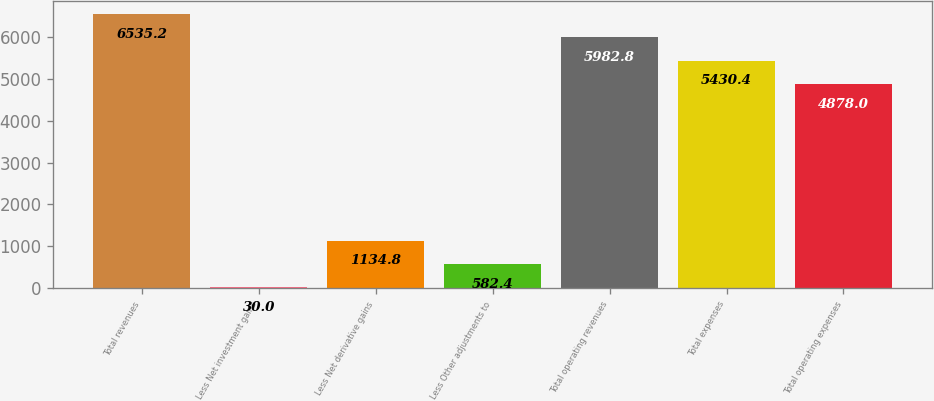<chart> <loc_0><loc_0><loc_500><loc_500><bar_chart><fcel>Total revenues<fcel>Less Net investment gains<fcel>Less Net derivative gains<fcel>Less Other adjustments to<fcel>Total operating revenues<fcel>Total expenses<fcel>Total operating expenses<nl><fcel>6535.2<fcel>30<fcel>1134.8<fcel>582.4<fcel>5982.8<fcel>5430.4<fcel>4878<nl></chart> 